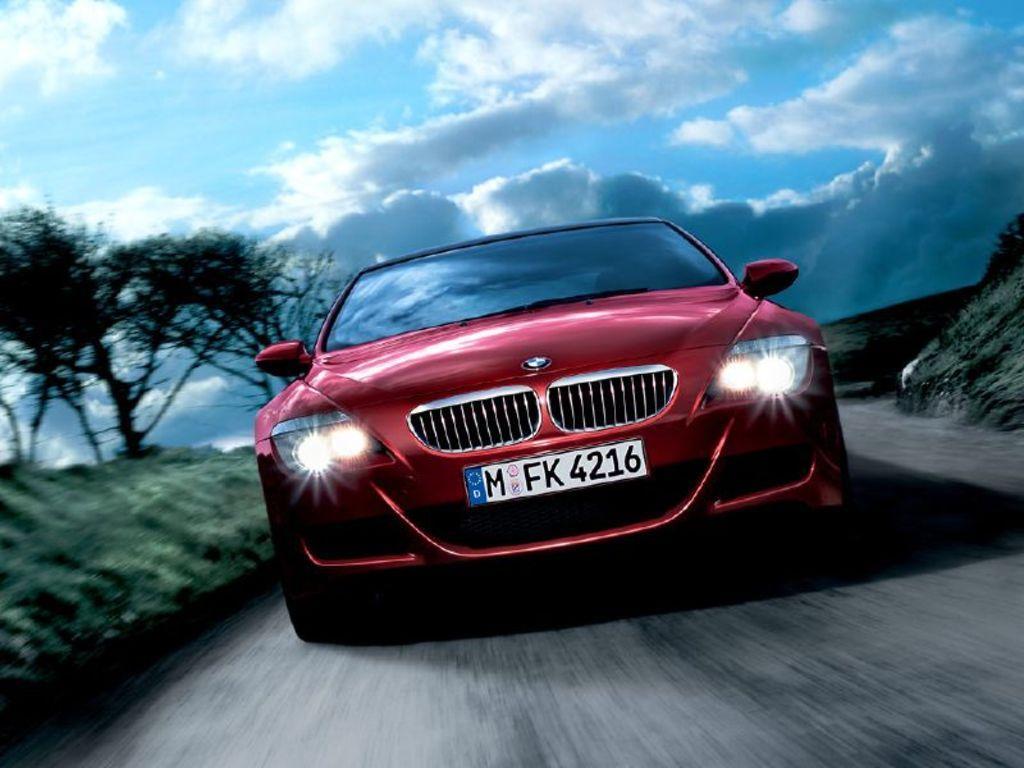In one or two sentences, can you explain what this image depicts? In this image there is a red colour car on the road. On the left side there are trees on the ground. At the top there is sky with the clouds. There are headlights to the car. 